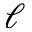<formula> <loc_0><loc_0><loc_500><loc_500>\ell</formula> 